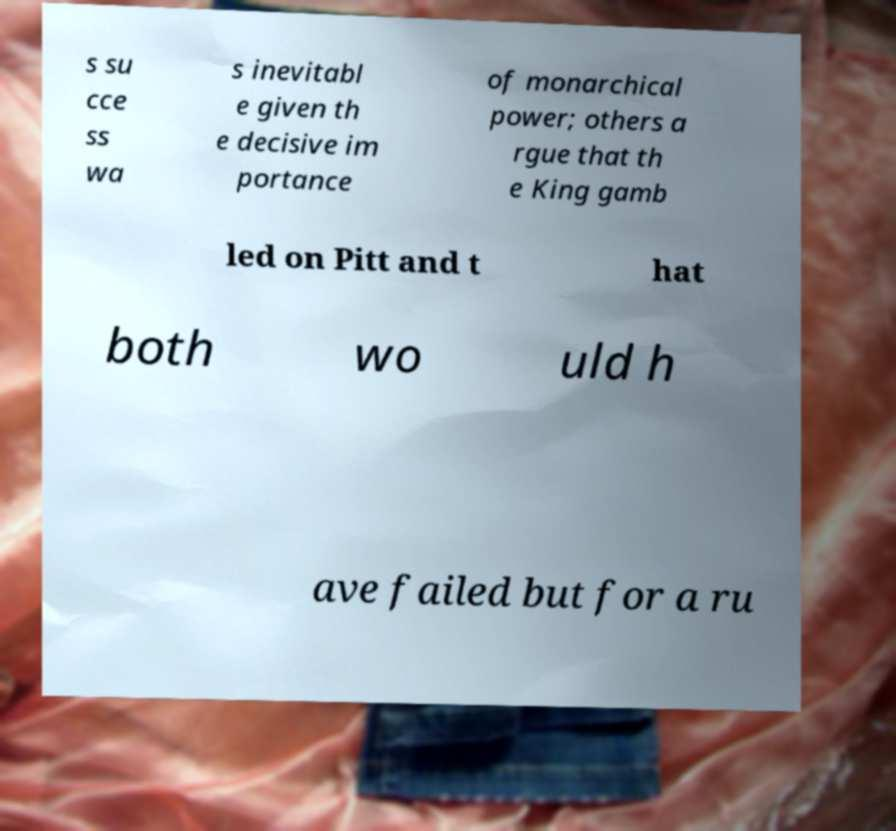Can you accurately transcribe the text from the provided image for me? s su cce ss wa s inevitabl e given th e decisive im portance of monarchical power; others a rgue that th e King gamb led on Pitt and t hat both wo uld h ave failed but for a ru 